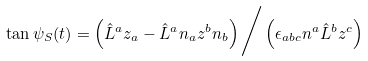<formula> <loc_0><loc_0><loc_500><loc_500>\tan \psi _ { S } ( t ) = \left ( \hat { L } ^ { a } z _ { a } - \hat { L } ^ { a } n _ { a } z ^ { b } n _ { b } \right ) \Big / \left ( \epsilon _ { a b c } n ^ { a } \hat { L } ^ { b } z ^ { c } \right )</formula> 